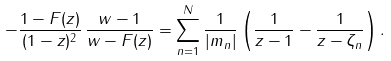Convert formula to latex. <formula><loc_0><loc_0><loc_500><loc_500>- \frac { 1 - F ( z ) } { ( 1 - z ) ^ { 2 } } \, \frac { w - 1 } { w - F ( z ) } = \sum _ { n = 1 } ^ { N } \frac { 1 } { | m _ { n } | } \left ( \frac { 1 } { z - 1 } - \frac { 1 } { z - \zeta _ { n } } \right ) .</formula> 